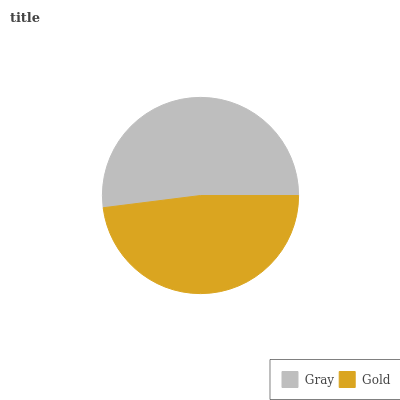Is Gold the minimum?
Answer yes or no. Yes. Is Gray the maximum?
Answer yes or no. Yes. Is Gold the maximum?
Answer yes or no. No. Is Gray greater than Gold?
Answer yes or no. Yes. Is Gold less than Gray?
Answer yes or no. Yes. Is Gold greater than Gray?
Answer yes or no. No. Is Gray less than Gold?
Answer yes or no. No. Is Gray the high median?
Answer yes or no. Yes. Is Gold the low median?
Answer yes or no. Yes. Is Gold the high median?
Answer yes or no. No. Is Gray the low median?
Answer yes or no. No. 